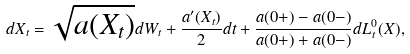<formula> <loc_0><loc_0><loc_500><loc_500>d X _ { t } = \sqrt { a ( X _ { t } ) } d W _ { t } + \frac { a ^ { \prime } ( X _ { t } ) } { 2 } d t + \frac { a ( 0 + ) - a ( 0 - ) } { a ( 0 + ) + a ( 0 - ) } d L _ { t } ^ { 0 } ( X ) ,</formula> 